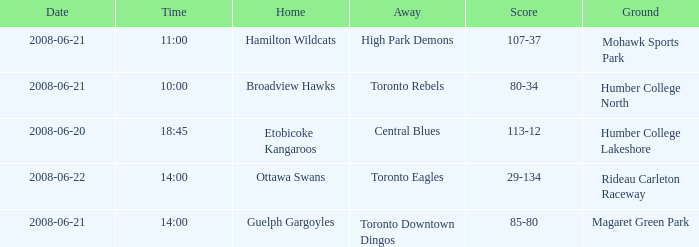Can you give me this table as a dict? {'header': ['Date', 'Time', 'Home', 'Away', 'Score', 'Ground'], 'rows': [['2008-06-21', '11:00', 'Hamilton Wildcats', 'High Park Demons', '107-37', 'Mohawk Sports Park'], ['2008-06-21', '10:00', 'Broadview Hawks', 'Toronto Rebels', '80-34', 'Humber College North'], ['2008-06-20', '18:45', 'Etobicoke Kangaroos', 'Central Blues', '113-12', 'Humber College Lakeshore'], ['2008-06-22', '14:00', 'Ottawa Swans', 'Toronto Eagles', '29-134', 'Rideau Carleton Raceway'], ['2008-06-21', '14:00', 'Guelph Gargoyles', 'Toronto Downtown Dingos', '85-80', 'Magaret Green Park']]} What is the Away with a Ground that is humber college north? Toronto Rebels. 